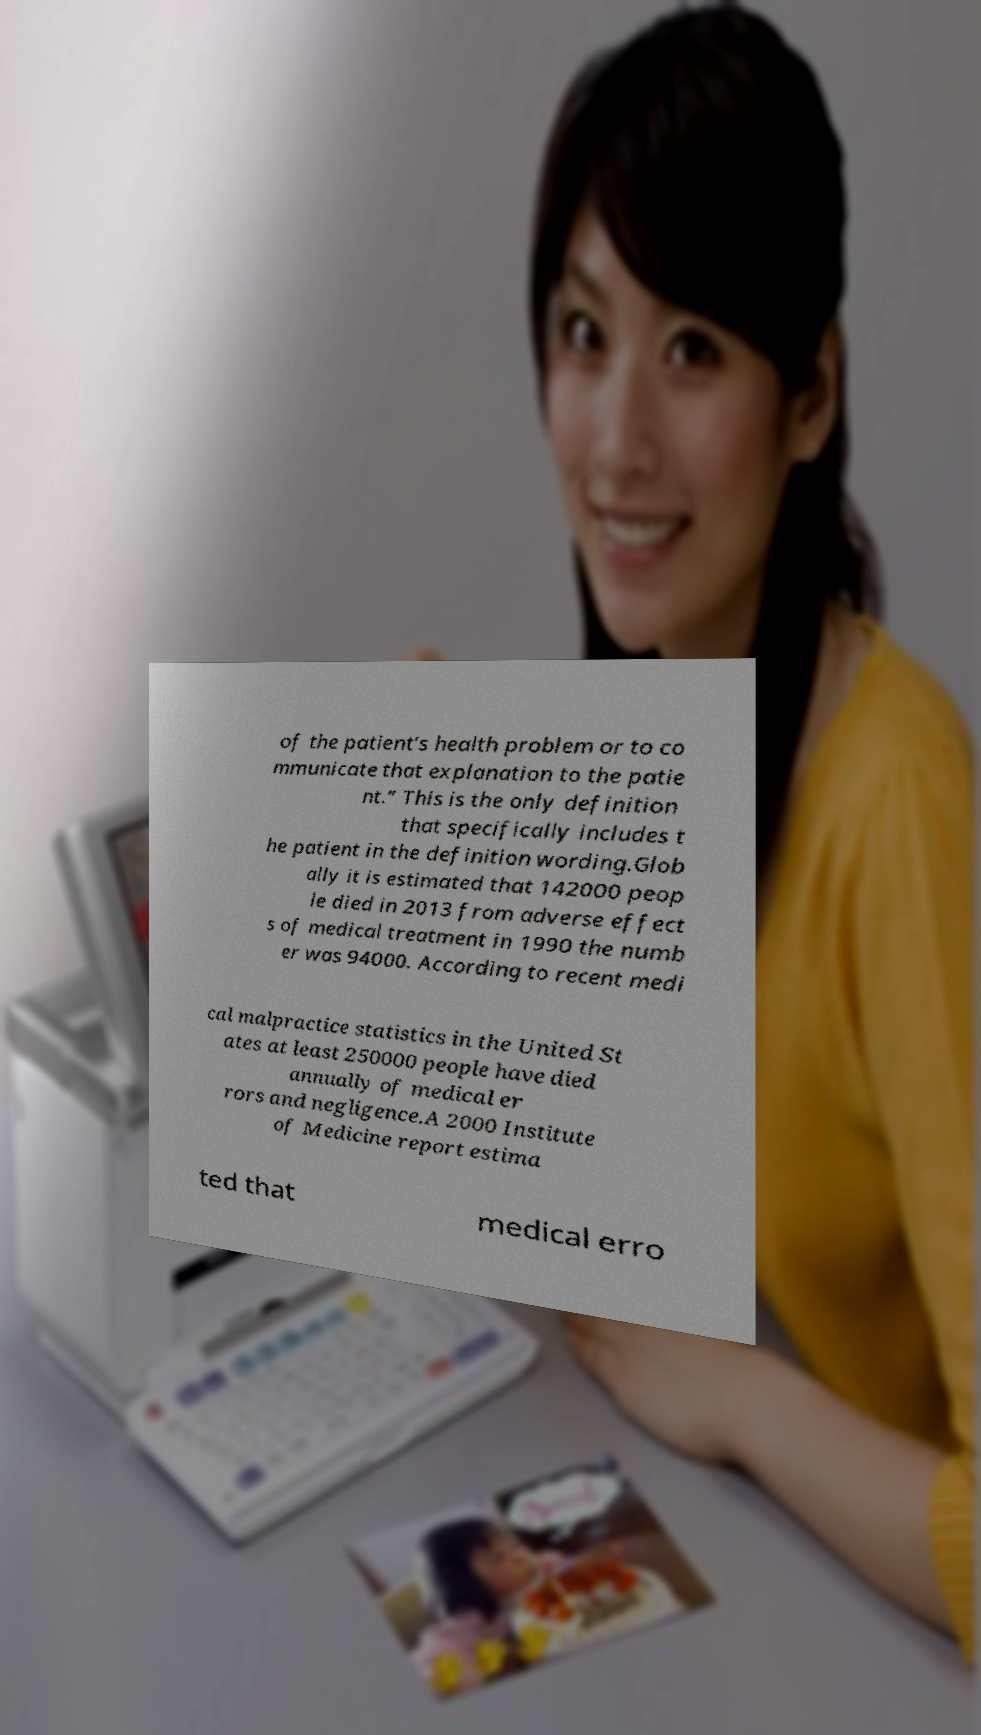Could you extract and type out the text from this image? of the patient’s health problem or to co mmunicate that explanation to the patie nt.” This is the only definition that specifically includes t he patient in the definition wording.Glob ally it is estimated that 142000 peop le died in 2013 from adverse effect s of medical treatment in 1990 the numb er was 94000. According to recent medi cal malpractice statistics in the United St ates at least 250000 people have died annually of medical er rors and negligence.A 2000 Institute of Medicine report estima ted that medical erro 